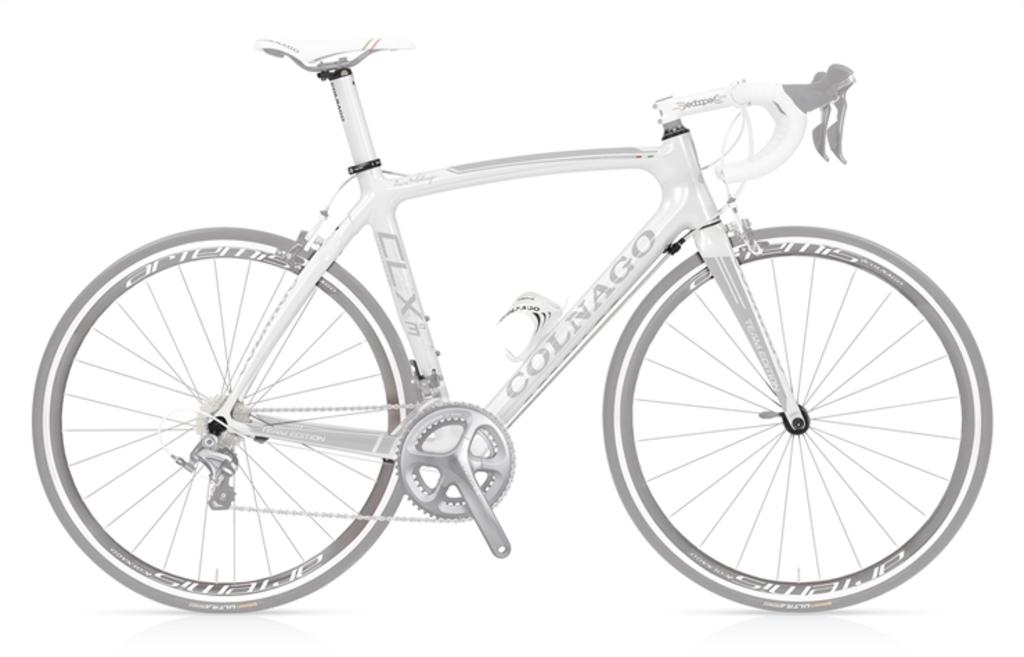What is the main object in the image? There is a cycle in the image. What colors are used for the cycle? The cycle is in white and ash color. Are there any words or letters on the cycle? Yes, there is text on the cycle. What type of surprise is hidden inside the cork in the image? There is no cork present in the image, and therefore no surprise can be found inside it. 